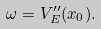<formula> <loc_0><loc_0><loc_500><loc_500>\omega = V ^ { \prime \prime } _ { E } ( x _ { 0 } ) .</formula> 